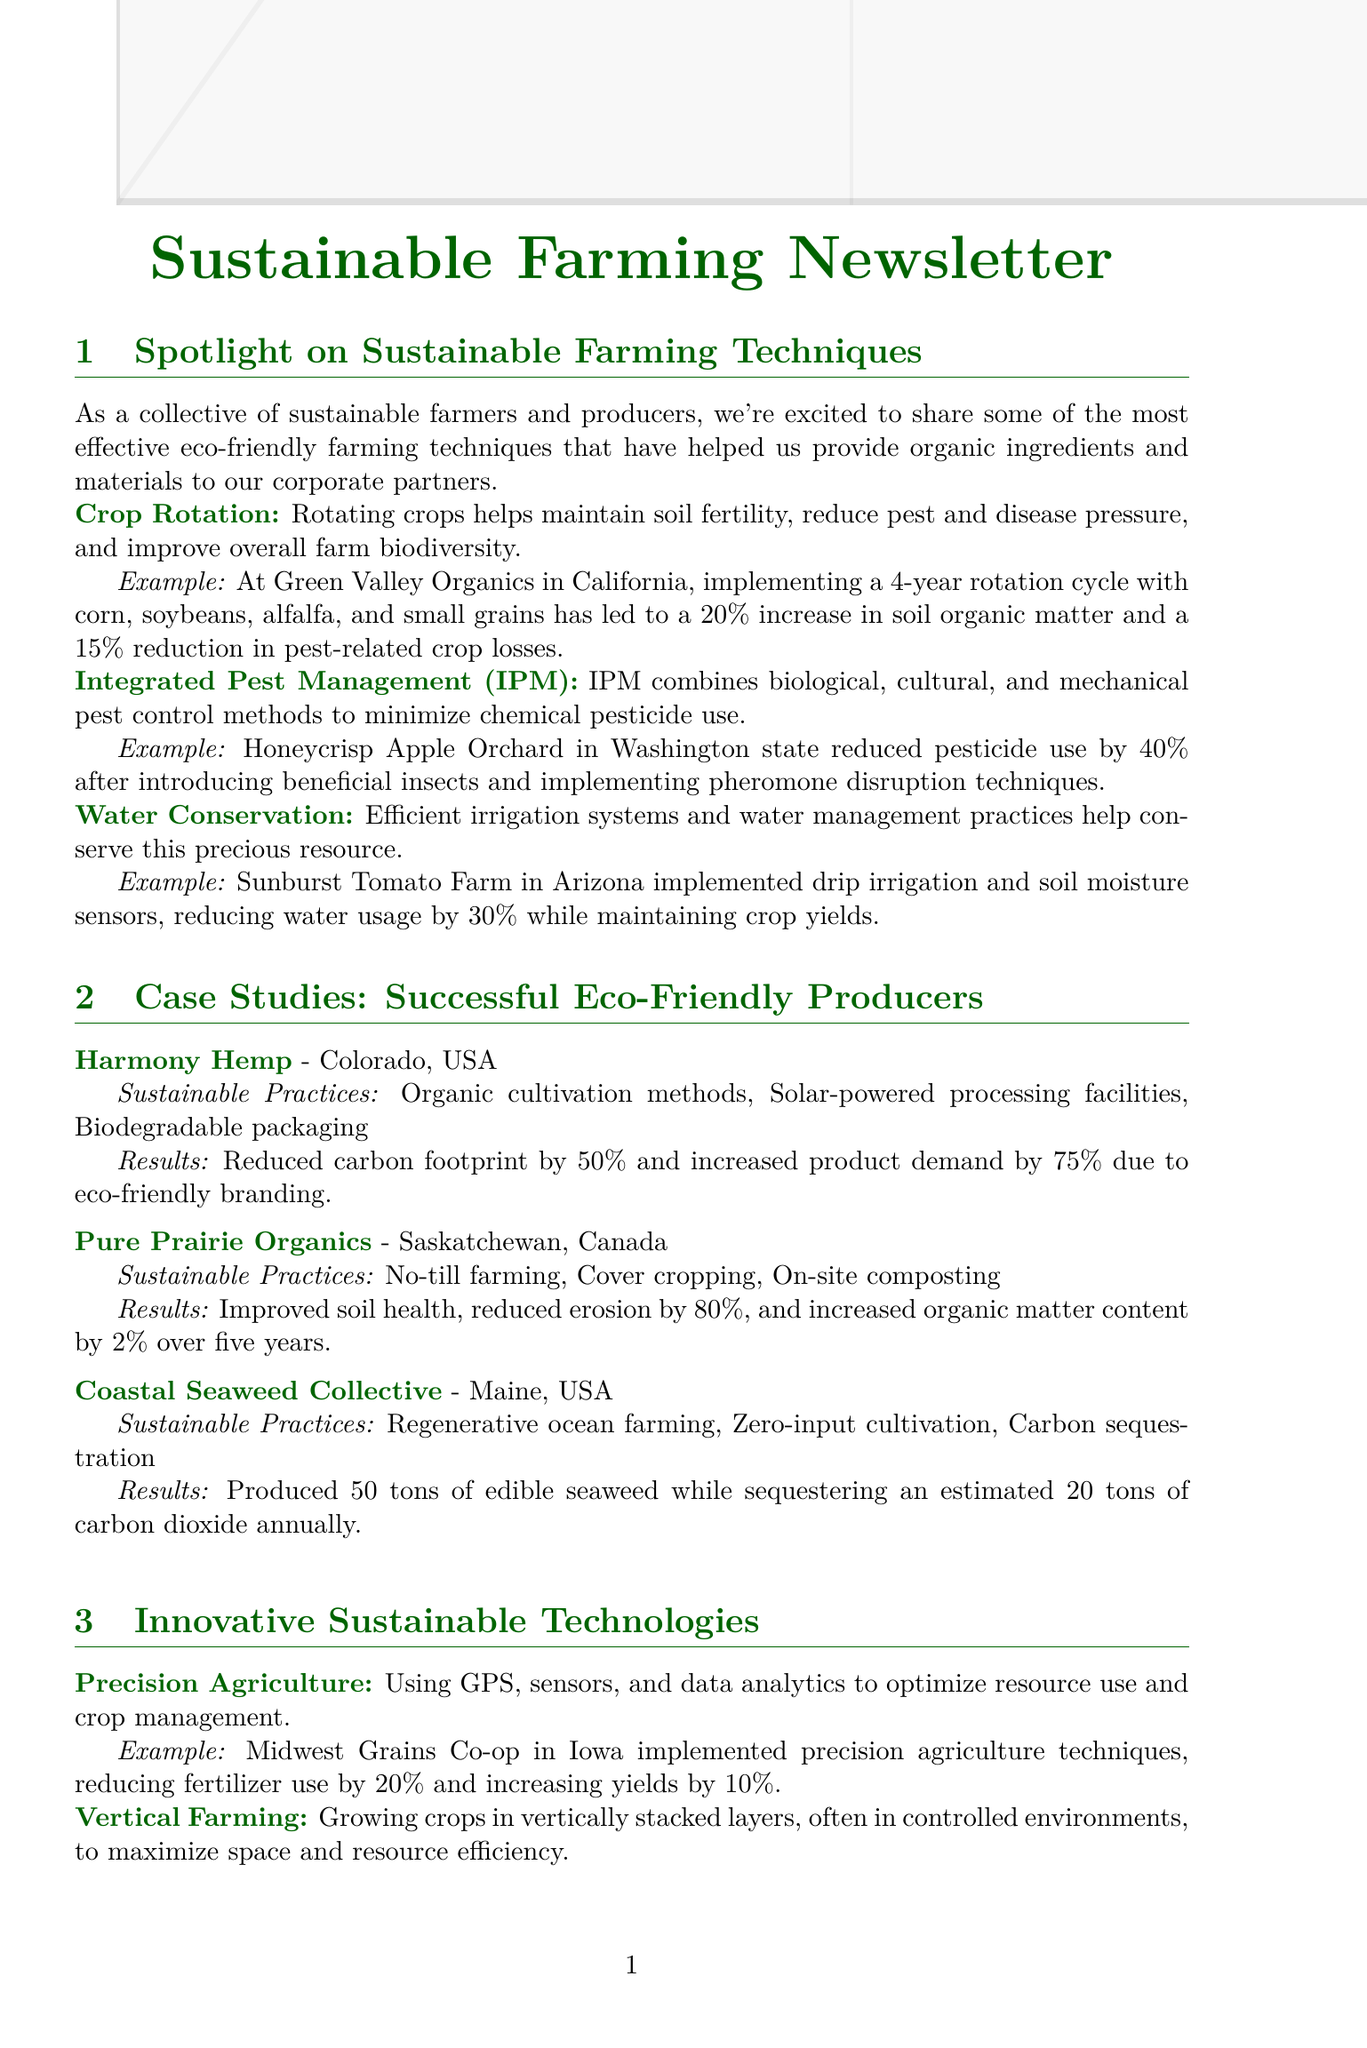What are the three sustainable farming techniques mentioned? The document lists Crop Rotation, Integrated Pest Management (IPM), and Water Conservation as sustainable farming techniques.
Answer: Crop Rotation, Integrated Pest Management (IPM), Water Conservation How much did Green Valley Organics increase soil organic matter? The increase in soil organic matter at Green Valley Organics due to crop rotation is specified as 20%.
Answer: 20% What was the percentage reduction in pesticide use by Honeycrisp Apple Orchard? The document states that Honeycrisp Apple Orchard reduced pesticide use by 40% after implementing sustainable practices.
Answer: 40% What sustainable practice did Harmony Hemp implement? The sustainable practices of Harmony Hemp include organic cultivation methods, solar-powered processing facilities, and biodegradable packaging.
Answer: Organic cultivation methods, solar-powered processing facilities, biodegradable packaging How much did Pure Prairie Organics reduce erosion? The document indicates that Pure Prairie Organics reduced erosion by 80% through sustainable farming practices.
Answer: 80% What increase in product demand did Harmony Hemp see? The increase in product demand at Harmony Hemp due to eco-friendly branding is noted as 75%.
Answer: 75% What type of packaging solution reduced plastic waste by 15 tons annually? The document mentions that Nature's Best Produce switched to compostable packaging, resulting in a reduction of plastic waste by 15 tons annually.
Answer: Compostable packaging What is the main focus of the newsletter? The newsletter focuses on sharing effective eco-friendly farming techniques and case studies from successful sustainable producers.
Answer: Sustainable farming techniques Which innovative technology used GPS and sensors? The document states that Precision Agriculture utilizes GPS, sensors, and data analytics for optimizing resource use.
Answer: Precision Agriculture 